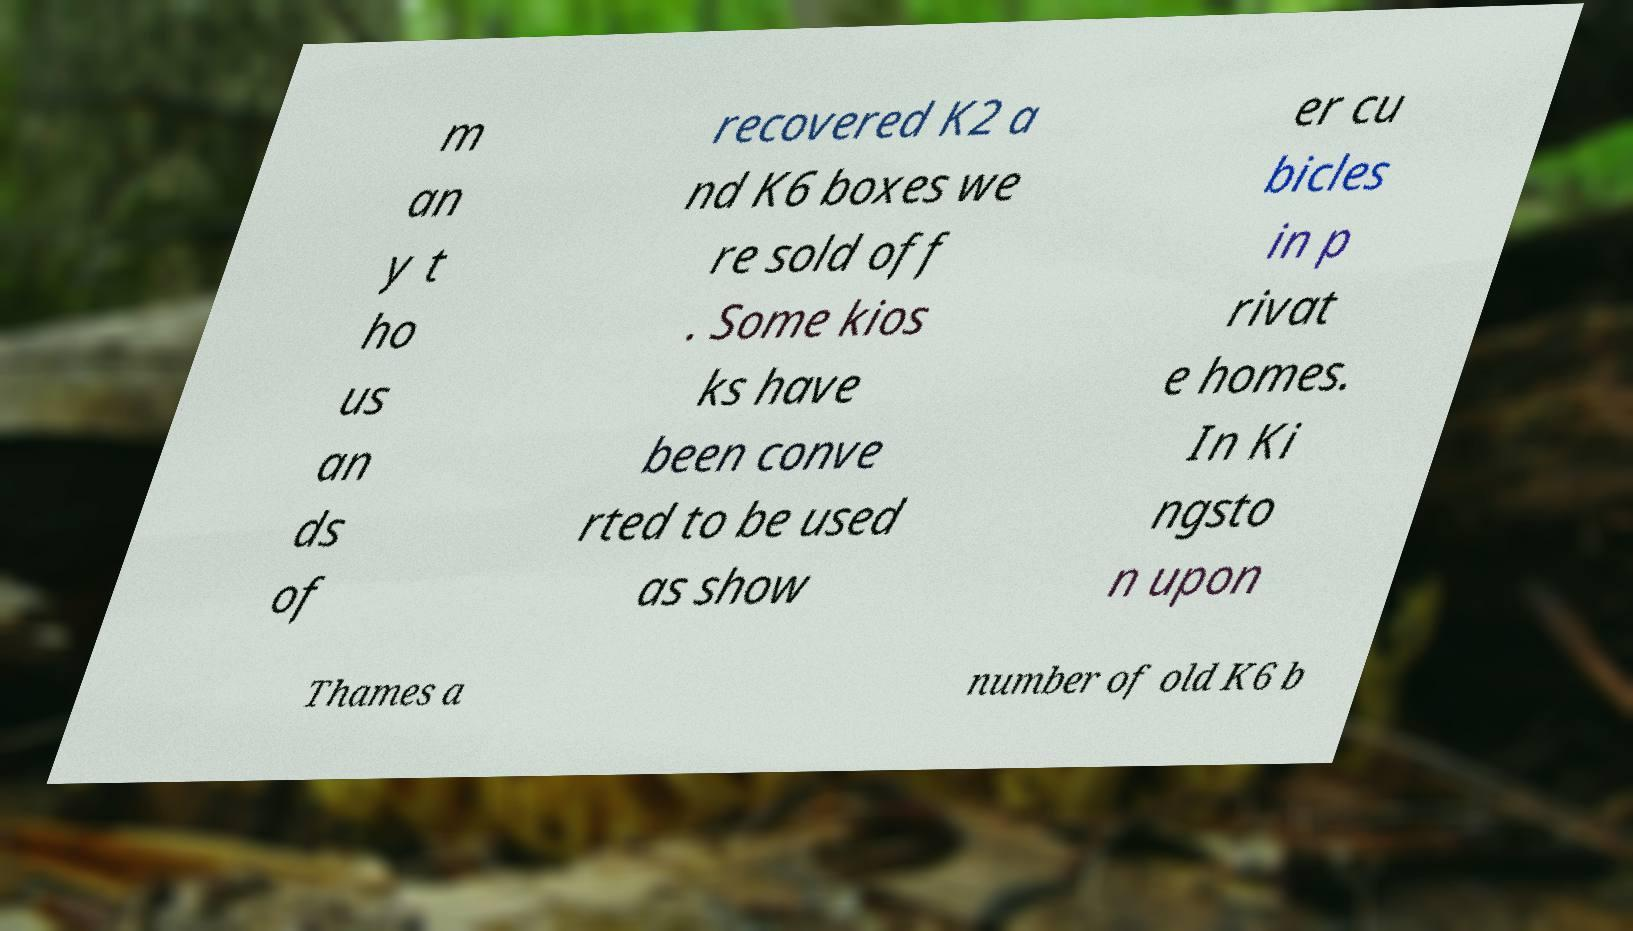Can you read and provide the text displayed in the image?This photo seems to have some interesting text. Can you extract and type it out for me? m an y t ho us an ds of recovered K2 a nd K6 boxes we re sold off . Some kios ks have been conve rted to be used as show er cu bicles in p rivat e homes. In Ki ngsto n upon Thames a number of old K6 b 